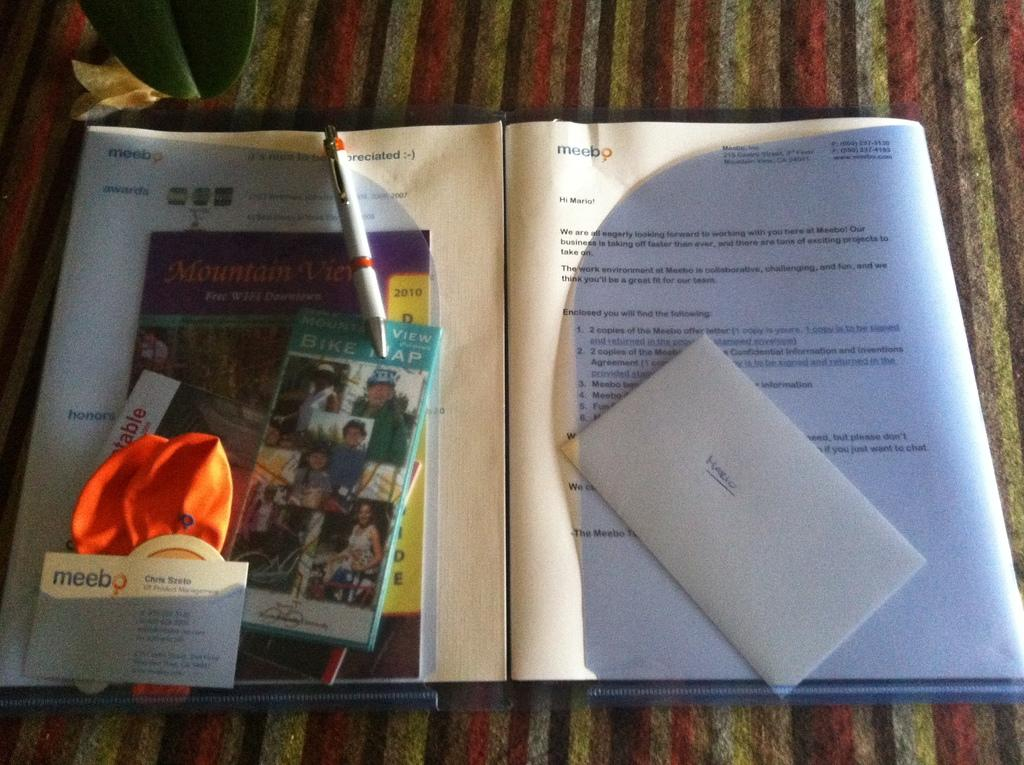<image>
Offer a succinct explanation of the picture presented. A folder full of papers, an envelope with the name Mario on it, and vacation brochures, is open on a table. 